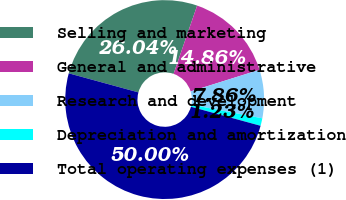Convert chart. <chart><loc_0><loc_0><loc_500><loc_500><pie_chart><fcel>Selling and marketing<fcel>General and administrative<fcel>Research and development<fcel>Depreciation and amortization<fcel>Total operating expenses (1)<nl><fcel>26.04%<fcel>14.86%<fcel>7.86%<fcel>1.23%<fcel>50.0%<nl></chart> 